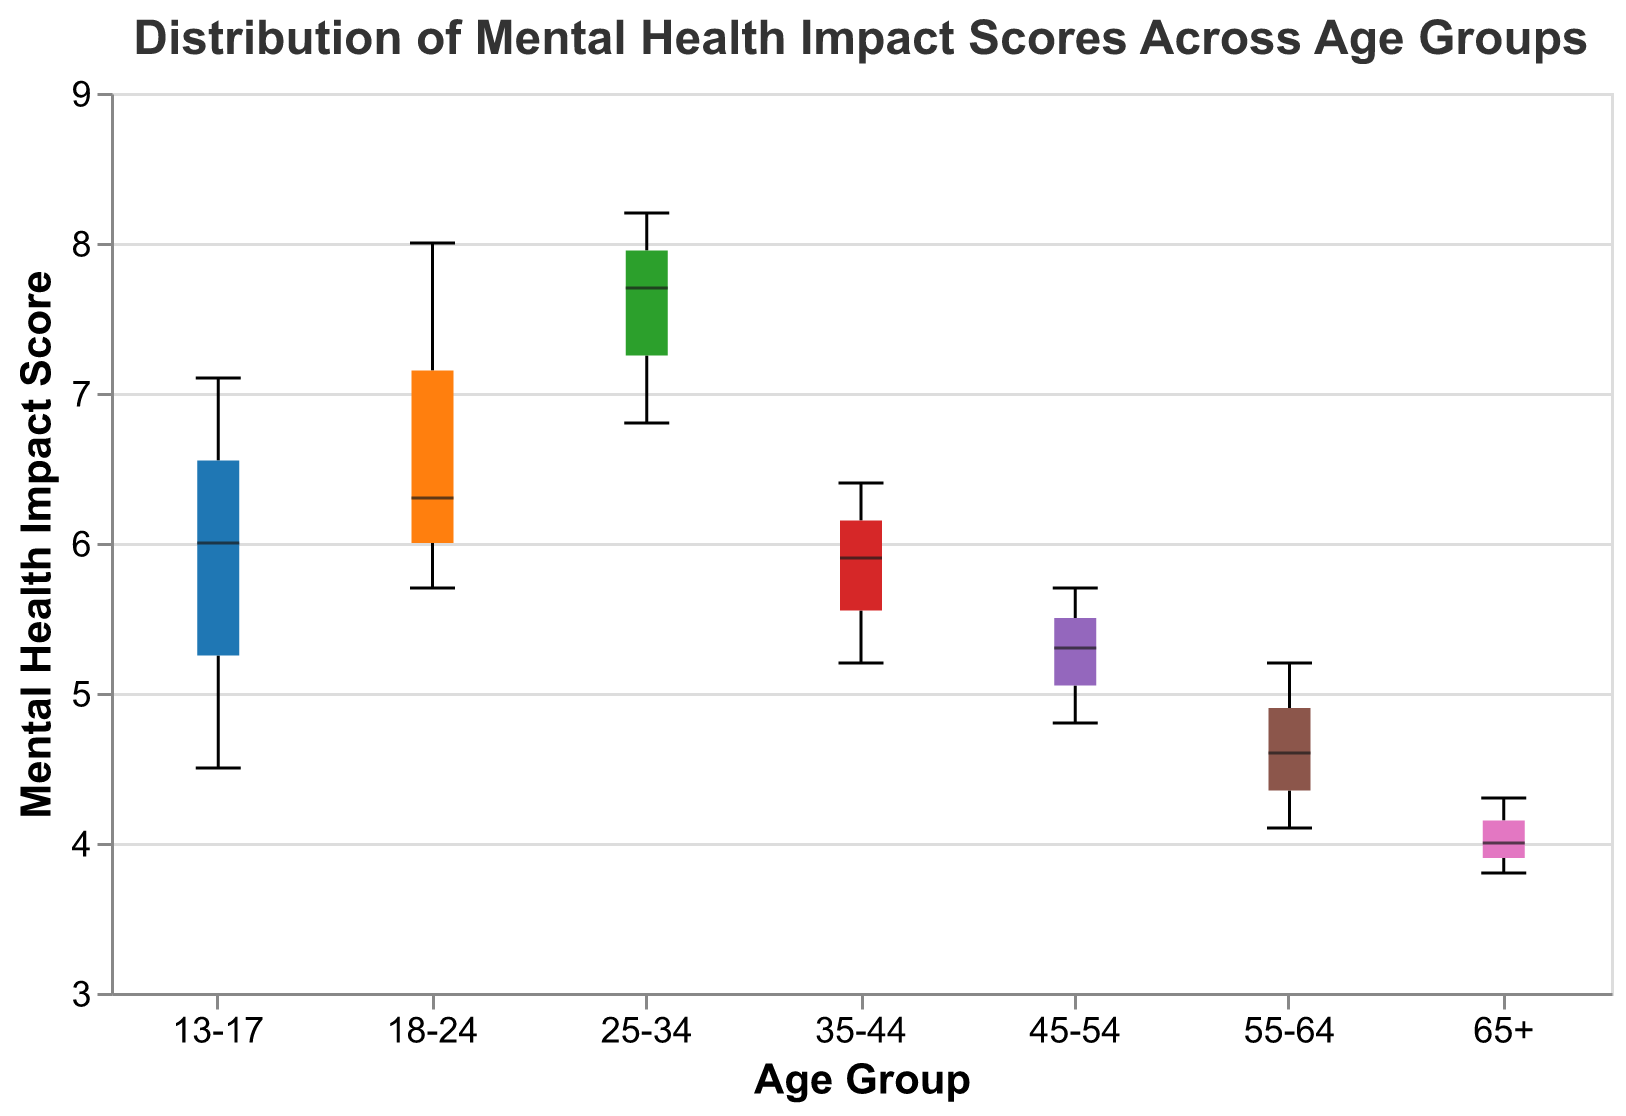What is the title of the figure? The title of the figure is displayed at the top and specifies the main subject of the chart.
Answer: Distribution of Mental Health Impact Scores Across Age Groups Which age group has the highest median mental health impact score? To determine the age group with the highest median, look at the lines within the boxes representing the medians for each age group. The highest line will indicate the highest median score.
Answer: 25-34 What is the range of mental health impact scores for the 18-24 age group? The range can be observed from the lowest point (whisker bottom) to the highest point (whisker top) for that group.
Answer: 5.7 to 8.0 Which age group has the narrowest interquartile range (IQR) of mental health impact scores? The IQR is represented by the height of the boxes. The age group with the shortest box has the narrowest IQR.
Answer: 55-64 How does the median score of the 45-54 age group compare with that of the 35-44 age group? Compare the lines within the boxes for both age groups. The group with the higher line has the higher median score.
Answer: 45-54 has a lower median than 35-44 What is the mental health impact score range for the 25-34 age group? The range extends from the minimum to the maximum scores represented by the whiskers.
Answer: 6.8 to 8.2 Which age group has the most consistent mental health impact score, as indicated by the smallest variability? The consistency can be inferred from the smallest range or smallest boxes (IQR).
Answer: 55-64 What is the median mental health impact score for the 13-17 age group? The median is indicated by the line inside the box for the 13-17 age group.
Answer: 6.0 Comparing the interquartile ranges, which age group has higher variability: 13-17 or 65+? Look at the height of the boxes for both groups to compare their IQRs. The taller box indicates higher variability.
Answer: 13-17 How do the mental health impact scores for individuals aged 55-64 compare with those aged 65+? Compare the positions of the boxes, whiskers, and medians between these two age groups to understand how their scores relate.
Answer: 55-64 have higher scores than 65+ 